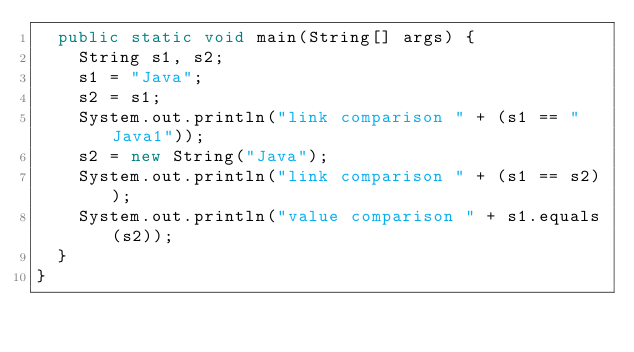<code> <loc_0><loc_0><loc_500><loc_500><_Java_>  public static void main(String[] args) {
    String s1, s2;
    s1 = "Java";
    s2 = s1;
    System.out.println("link comparison " + (s1 == "Java1"));
    s2 = new String("Java");
    System.out.println("link comparison " + (s1 == s2));
    System.out.println("value comparison " + s1.equals(s2));
  }
}
</code> 